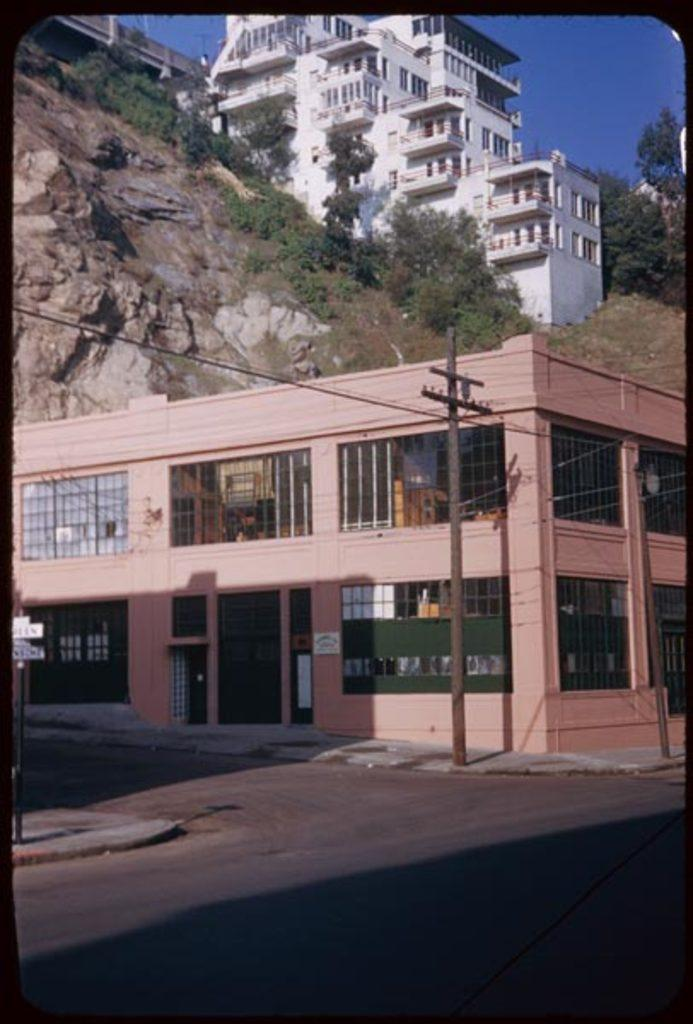What type of structure is present in the image? There is a building in the image. What is the color of the building? The building is pink in color. What can be seen behind the building? There is a mountain behind the building. What else is present on the mountain? There are buildings and trees on the mountain. What type of fuel is being used by the sock in the image? There is no sock present in the image, so it is not possible to determine what type of fuel it might be using. 